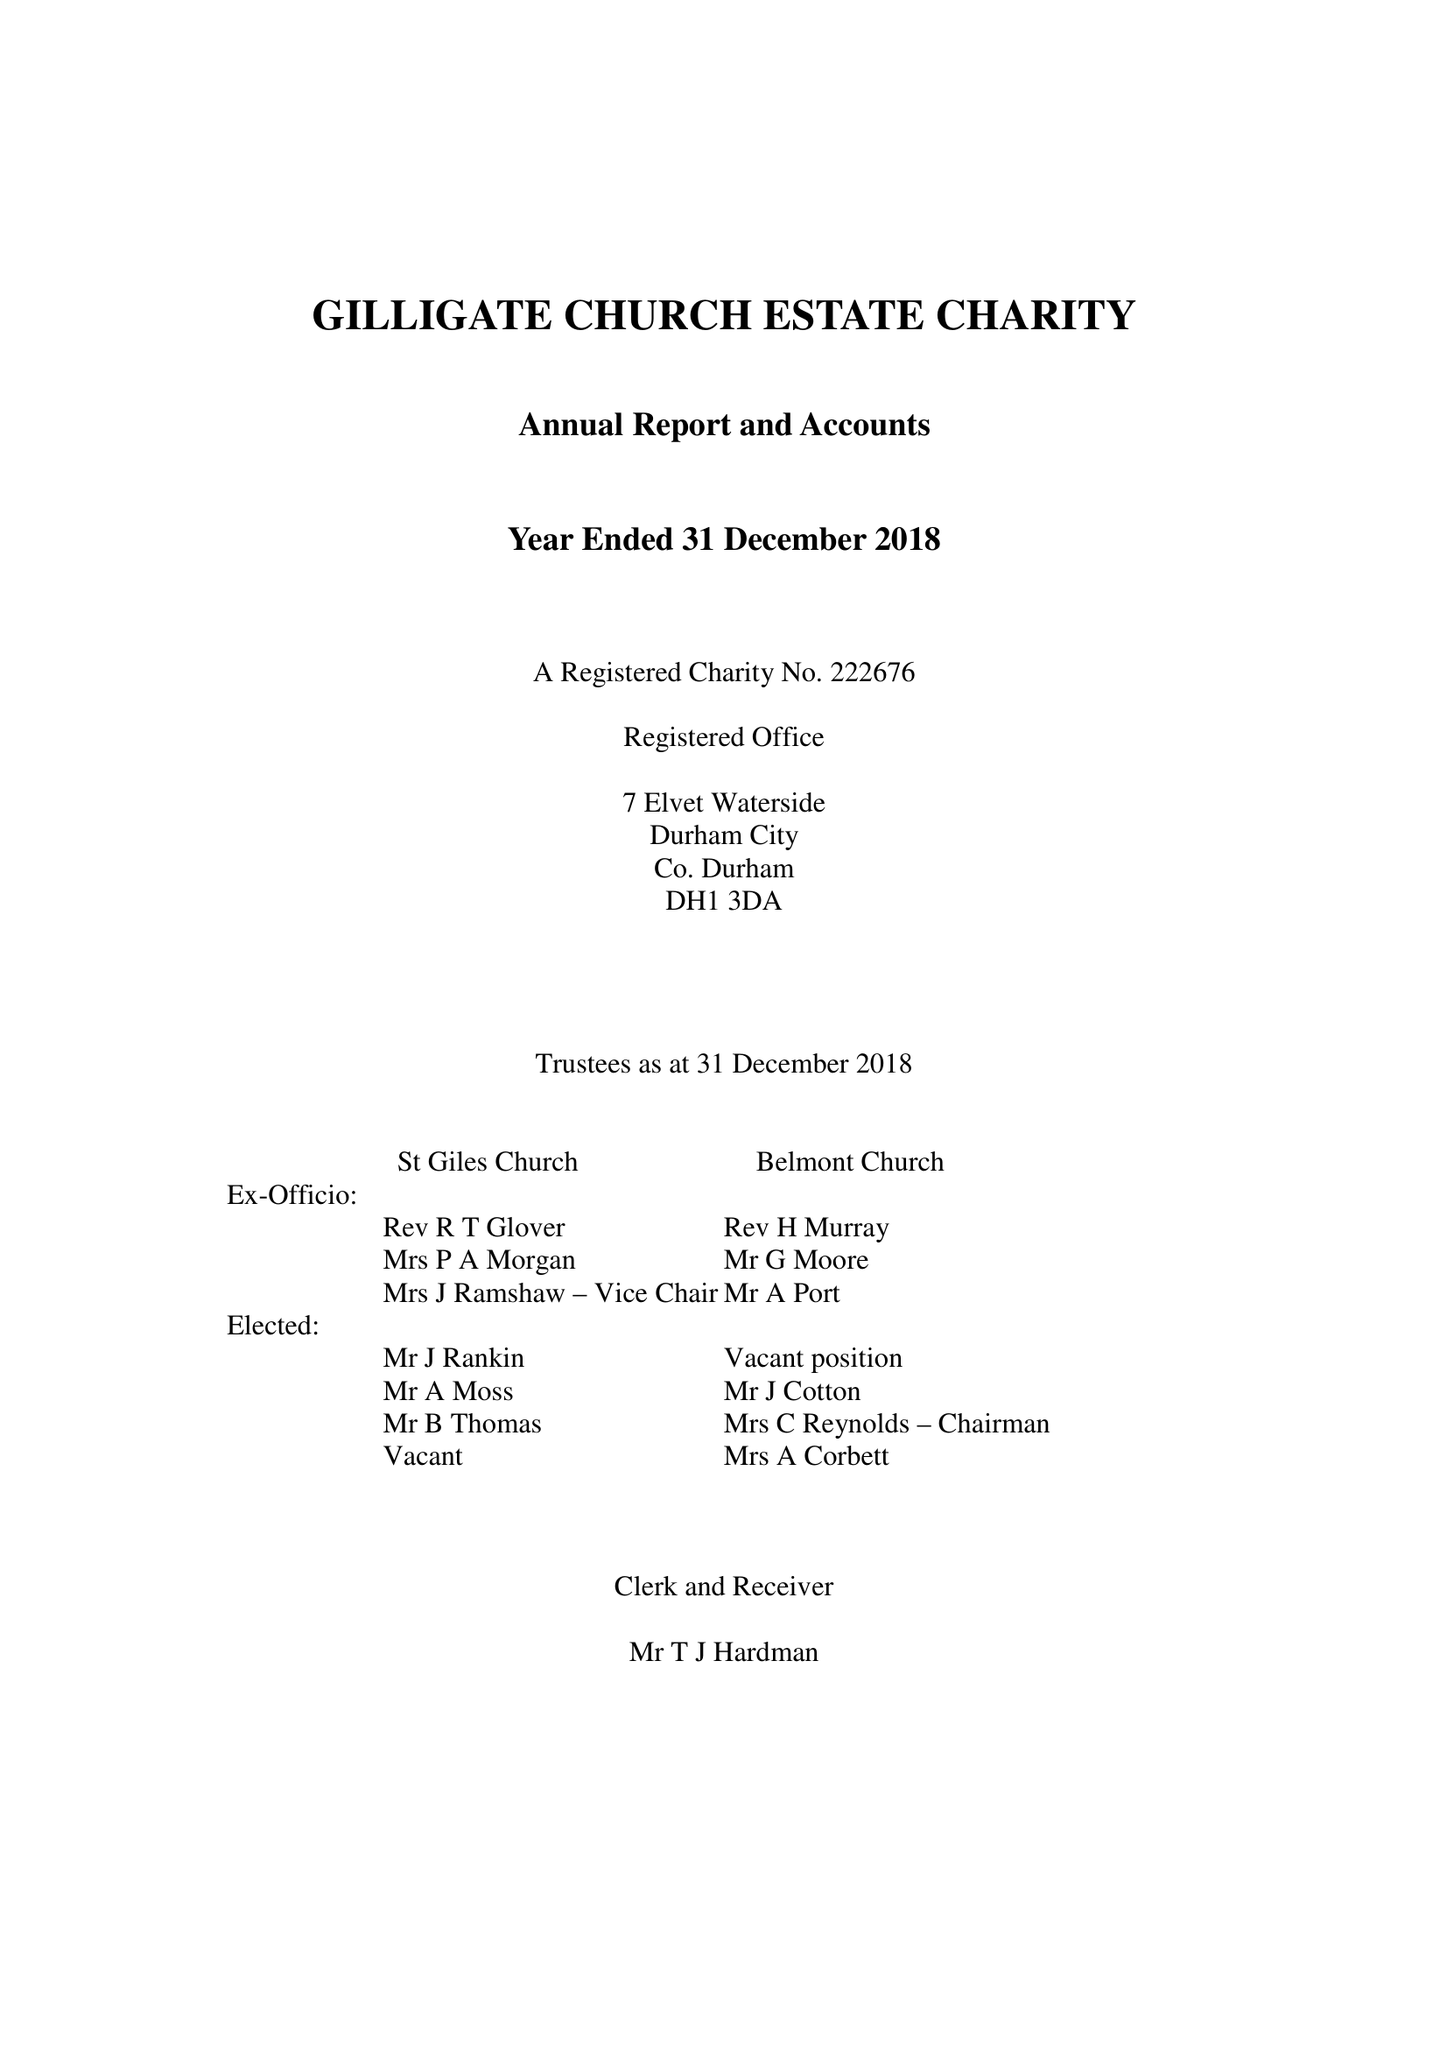What is the value for the report_date?
Answer the question using a single word or phrase. 2018-12-31 